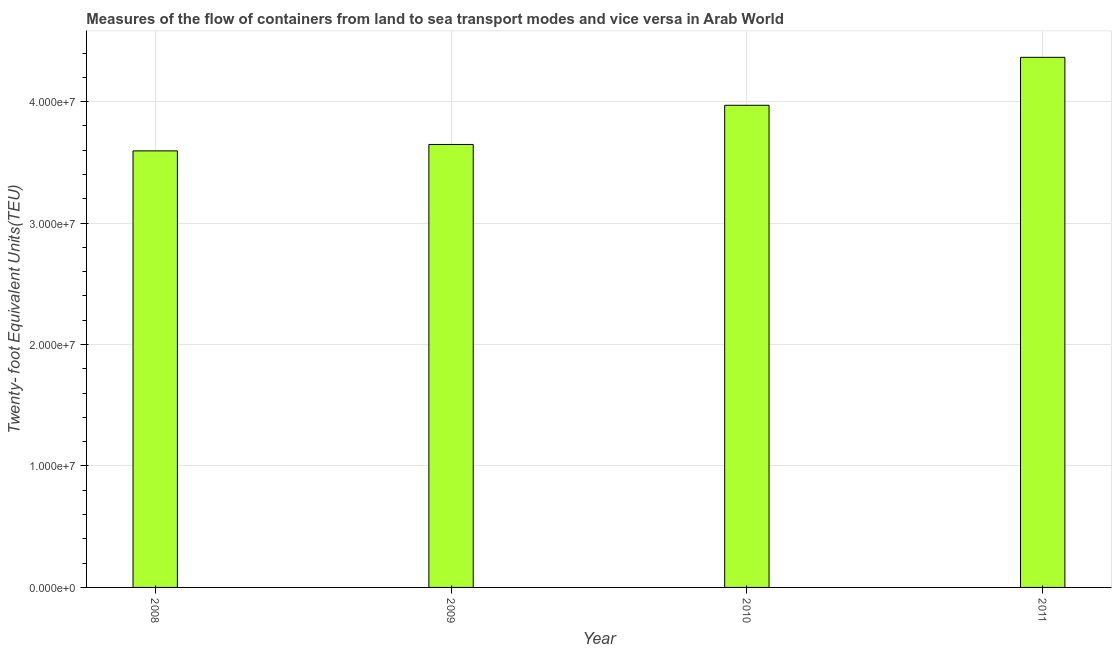Does the graph contain any zero values?
Offer a terse response. No. Does the graph contain grids?
Your answer should be very brief. Yes. What is the title of the graph?
Your response must be concise. Measures of the flow of containers from land to sea transport modes and vice versa in Arab World. What is the label or title of the X-axis?
Offer a very short reply. Year. What is the label or title of the Y-axis?
Your response must be concise. Twenty- foot Equivalent Units(TEU). What is the container port traffic in 2010?
Give a very brief answer. 3.97e+07. Across all years, what is the maximum container port traffic?
Offer a very short reply. 4.36e+07. Across all years, what is the minimum container port traffic?
Your response must be concise. 3.59e+07. In which year was the container port traffic maximum?
Provide a succinct answer. 2011. What is the sum of the container port traffic?
Give a very brief answer. 1.56e+08. What is the difference between the container port traffic in 2008 and 2011?
Give a very brief answer. -7.70e+06. What is the average container port traffic per year?
Offer a very short reply. 3.89e+07. What is the median container port traffic?
Offer a terse response. 3.81e+07. What is the ratio of the container port traffic in 2010 to that in 2011?
Provide a succinct answer. 0.91. Is the container port traffic in 2010 less than that in 2011?
Provide a succinct answer. Yes. What is the difference between the highest and the second highest container port traffic?
Your answer should be compact. 3.95e+06. What is the difference between the highest and the lowest container port traffic?
Provide a succinct answer. 7.70e+06. In how many years, is the container port traffic greater than the average container port traffic taken over all years?
Your answer should be compact. 2. How many years are there in the graph?
Your answer should be very brief. 4. Are the values on the major ticks of Y-axis written in scientific E-notation?
Offer a terse response. Yes. What is the Twenty- foot Equivalent Units(TEU) in 2008?
Offer a very short reply. 3.59e+07. What is the Twenty- foot Equivalent Units(TEU) in 2009?
Give a very brief answer. 3.65e+07. What is the Twenty- foot Equivalent Units(TEU) of 2010?
Make the answer very short. 3.97e+07. What is the Twenty- foot Equivalent Units(TEU) in 2011?
Give a very brief answer. 4.36e+07. What is the difference between the Twenty- foot Equivalent Units(TEU) in 2008 and 2009?
Offer a terse response. -5.29e+05. What is the difference between the Twenty- foot Equivalent Units(TEU) in 2008 and 2010?
Your response must be concise. -3.75e+06. What is the difference between the Twenty- foot Equivalent Units(TEU) in 2008 and 2011?
Make the answer very short. -7.70e+06. What is the difference between the Twenty- foot Equivalent Units(TEU) in 2009 and 2010?
Provide a succinct answer. -3.22e+06. What is the difference between the Twenty- foot Equivalent Units(TEU) in 2009 and 2011?
Your answer should be compact. -7.17e+06. What is the difference between the Twenty- foot Equivalent Units(TEU) in 2010 and 2011?
Provide a short and direct response. -3.95e+06. What is the ratio of the Twenty- foot Equivalent Units(TEU) in 2008 to that in 2009?
Provide a short and direct response. 0.98. What is the ratio of the Twenty- foot Equivalent Units(TEU) in 2008 to that in 2010?
Ensure brevity in your answer.  0.91. What is the ratio of the Twenty- foot Equivalent Units(TEU) in 2008 to that in 2011?
Give a very brief answer. 0.82. What is the ratio of the Twenty- foot Equivalent Units(TEU) in 2009 to that in 2010?
Your answer should be compact. 0.92. What is the ratio of the Twenty- foot Equivalent Units(TEU) in 2009 to that in 2011?
Give a very brief answer. 0.84. What is the ratio of the Twenty- foot Equivalent Units(TEU) in 2010 to that in 2011?
Give a very brief answer. 0.91. 